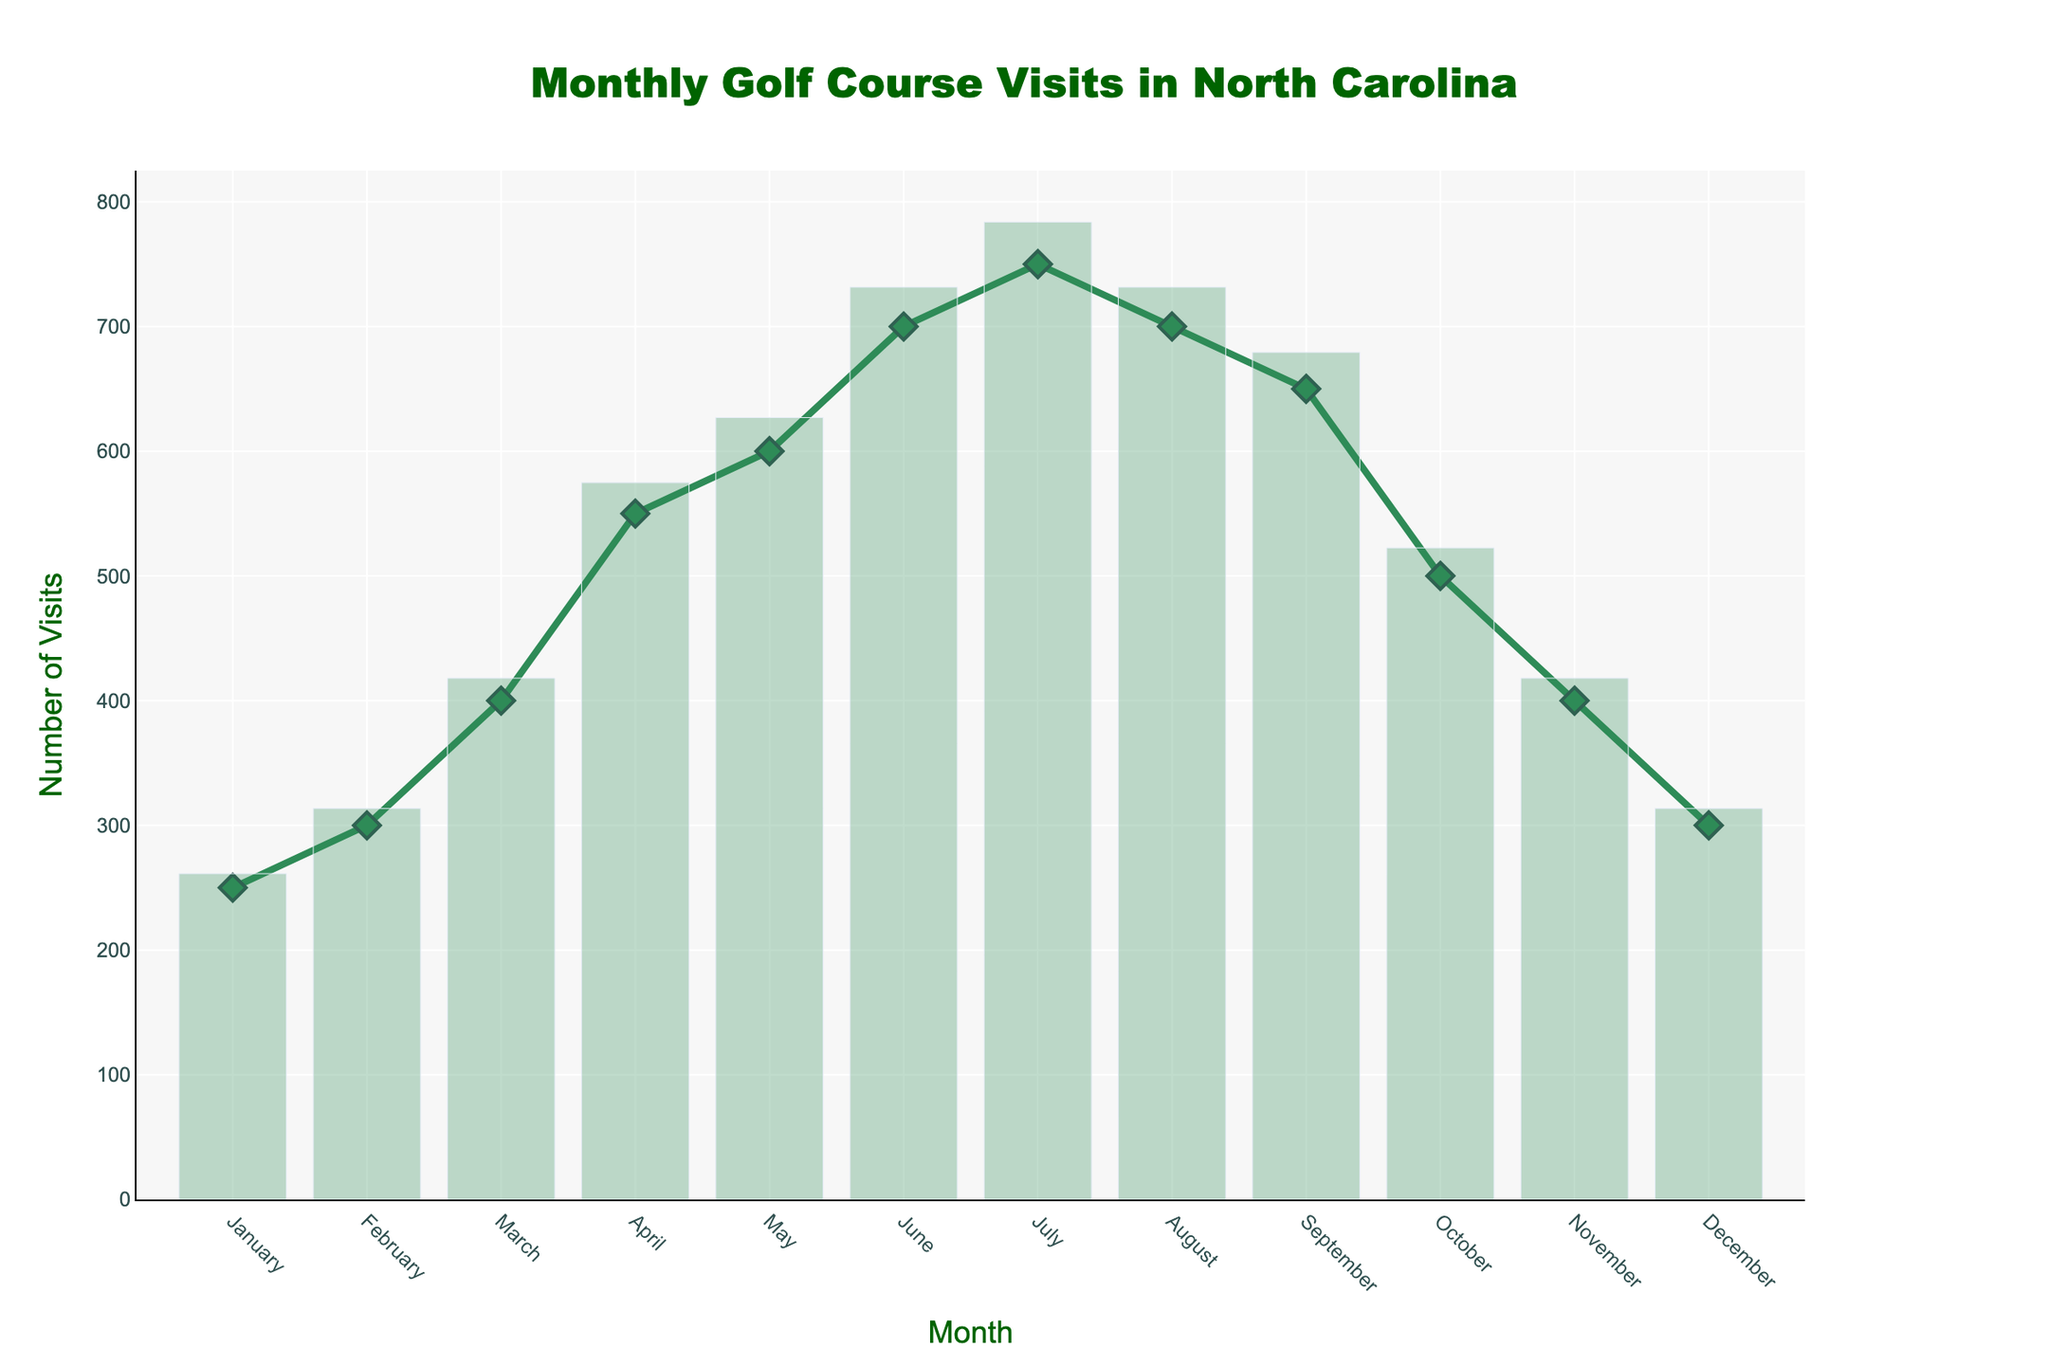What's the title of the plot? The title is typically found at the top of the figure. It clearly indicates what the data represents.
Answer: Monthly Golf Course Visits in North Carolina What month had the highest number of visits? By observing the peak in the plot, the highest point indicates the month with the most visits.
Answer: July How many visits occurred in February? Look at the data point for February on the x-axis and read the corresponding y-value.
Answer: 300 Which months had fewer than 400 visits? Identify the months where the data points fall below the 400 mark on the y-axis.
Answer: January, February, November, and December What's the total number of visits in the winter months (December, January, February)? Sum the number of visits for December, January, and February: 300 + 250 + 300.
Answer: 850 How many more visits were there in July compared to March? Subtract the number of visits in March from the number of visits in July: 750 - 400.
Answer: 350 Which month had the largest increase in visits compared to the previous month? Observe the differences in visits between consecutive months and identify the largest increase.
Answer: March to April What is the trend of visits from January to July? Examine the plot from January to July to determine if the numbers are generally increasing, decreasing, or stable.
Answer: Increasing What's the average number of visits from April to September? Sum the visits from April to September and divide by the number of months: (550 + 600 + 700 + 750 + 700 + 650) / 6.
Answer: 658.33 When do visits start to decrease after the peak month? Find the peak month and identify when the trend starts to go downwards.
Answer: After July 